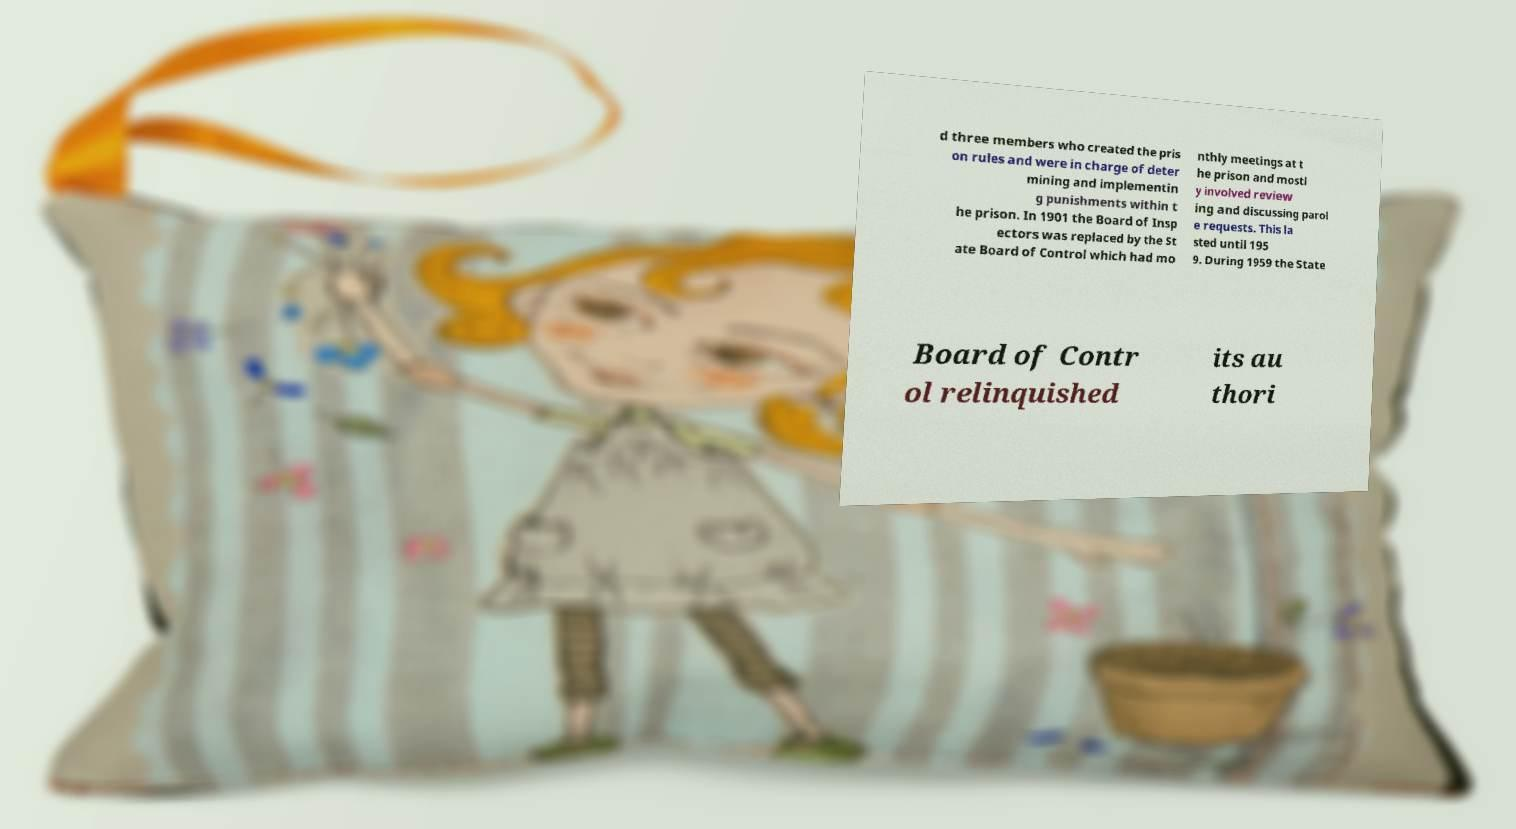Please read and relay the text visible in this image. What does it say? d three members who created the pris on rules and were in charge of deter mining and implementin g punishments within t he prison. In 1901 the Board of Insp ectors was replaced by the St ate Board of Control which had mo nthly meetings at t he prison and mostl y involved review ing and discussing parol e requests. This la sted until 195 9. During 1959 the State Board of Contr ol relinquished its au thori 